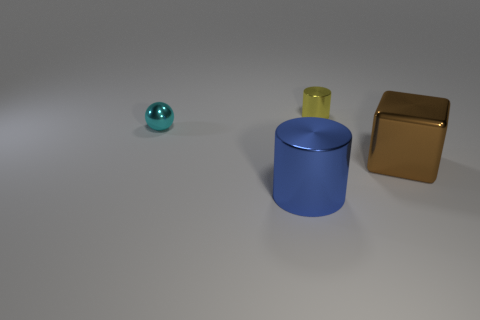Add 2 small yellow cubes. How many objects exist? 6 Subtract all spheres. How many objects are left? 3 Add 3 large shiny things. How many large shiny things are left? 5 Add 3 cyan balls. How many cyan balls exist? 4 Subtract 0 cyan cubes. How many objects are left? 4 Subtract all large gray matte cylinders. Subtract all tiny yellow metallic objects. How many objects are left? 3 